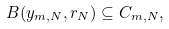Convert formula to latex. <formula><loc_0><loc_0><loc_500><loc_500>& B ( y _ { m , N } , r _ { N } ) \subseteq C _ { m , N } ,</formula> 